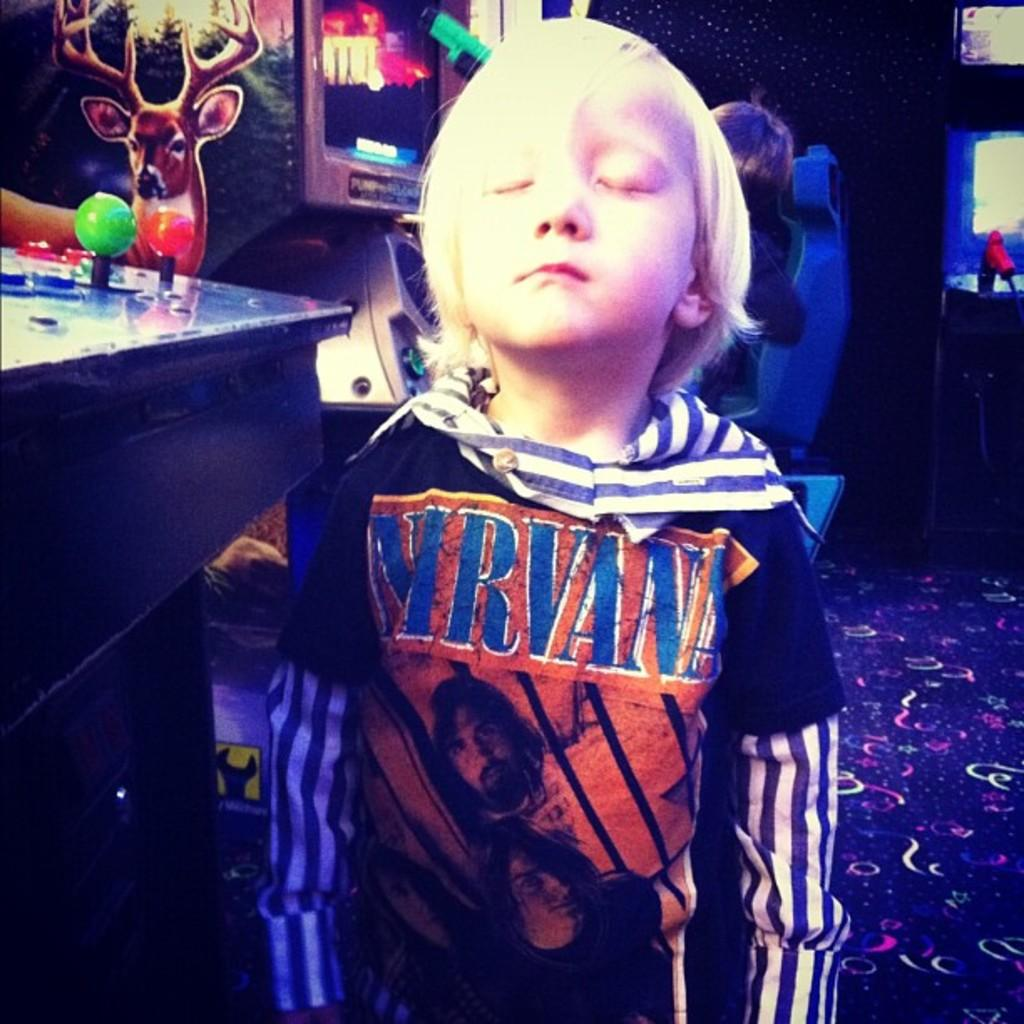<image>
Share a concise interpretation of the image provided. A little blonde boy with Nirvana on his shirt 